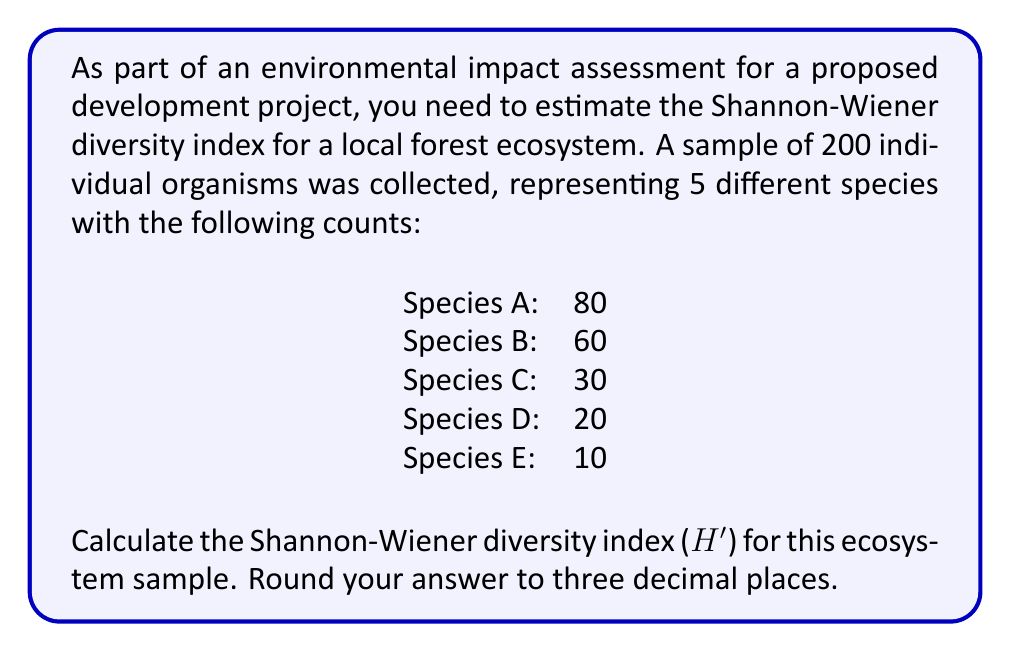Show me your answer to this math problem. The Shannon-Wiener diversity index (H') is a measure of biodiversity that takes into account both species richness and evenness. It is calculated using the formula:

$$H' = -\sum_{i=1}^{R} p_i \ln(p_i)$$

Where:
- $R$ is the number of species
- $p_i$ is the proportion of individuals belonging to the $i$-th species

To calculate H':

1. Calculate the total number of individuals:
   $N = 80 + 60 + 30 + 20 + 10 = 200$

2. Calculate the proportion ($p_i$) for each species:
   Species A: $p_1 = 80/200 = 0.4$
   Species B: $p_2 = 60/200 = 0.3$
   Species C: $p_3 = 30/200 = 0.15$
   Species D: $p_4 = 20/200 = 0.1$
   Species E: $p_5 = 10/200 = 0.05$

3. Calculate $p_i \ln(p_i)$ for each species:
   Species A: $0.4 \ln(0.4) = -0.3665$
   Species B: $0.3 \ln(0.3) = -0.3611$
   Species C: $0.15 \ln(0.15) = -0.2843$
   Species D: $0.1 \ln(0.1) = -0.2303$
   Species E: $0.05 \ln(0.05) = -0.1498$

4. Sum the negative values:
   $H' = -(-0.3665 - 0.3611 - 0.2843 - 0.2303 - 0.1498)$

5. Calculate the final result:
   $H' = 1.3920$

Rounded to three decimal places, the Shannon-Wiener diversity index is 1.392.
Answer: 1.392 